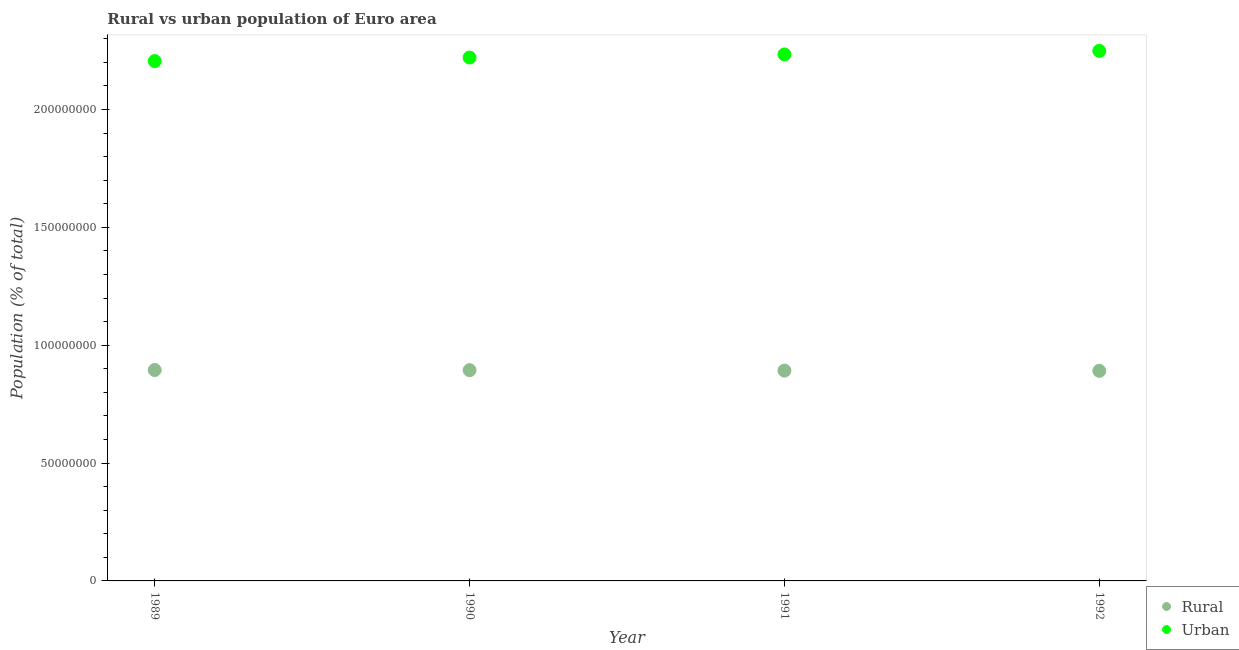What is the urban population density in 1992?
Your answer should be compact. 2.25e+08. Across all years, what is the maximum urban population density?
Offer a terse response. 2.25e+08. Across all years, what is the minimum rural population density?
Provide a succinct answer. 8.91e+07. In which year was the rural population density minimum?
Make the answer very short. 1992. What is the total urban population density in the graph?
Offer a terse response. 8.91e+08. What is the difference between the rural population density in 1989 and that in 1992?
Offer a very short reply. 3.51e+05. What is the difference between the urban population density in 1989 and the rural population density in 1990?
Keep it short and to the point. 1.31e+08. What is the average rural population density per year?
Provide a short and direct response. 8.93e+07. In the year 1991, what is the difference between the urban population density and rural population density?
Make the answer very short. 1.34e+08. In how many years, is the rural population density greater than 90000000 %?
Keep it short and to the point. 0. What is the ratio of the urban population density in 1989 to that in 1990?
Make the answer very short. 0.99. Is the urban population density in 1989 less than that in 1991?
Offer a very short reply. Yes. Is the difference between the urban population density in 1989 and 1990 greater than the difference between the rural population density in 1989 and 1990?
Offer a terse response. No. What is the difference between the highest and the second highest urban population density?
Your response must be concise. 1.51e+06. What is the difference between the highest and the lowest urban population density?
Keep it short and to the point. 4.34e+06. Is the urban population density strictly greater than the rural population density over the years?
Give a very brief answer. Yes. Is the urban population density strictly less than the rural population density over the years?
Provide a short and direct response. No. How many dotlines are there?
Your answer should be compact. 2. What is the difference between two consecutive major ticks on the Y-axis?
Ensure brevity in your answer.  5.00e+07. Are the values on the major ticks of Y-axis written in scientific E-notation?
Offer a terse response. No. How many legend labels are there?
Ensure brevity in your answer.  2. What is the title of the graph?
Give a very brief answer. Rural vs urban population of Euro area. Does "Non-residents" appear as one of the legend labels in the graph?
Your answer should be very brief. No. What is the label or title of the Y-axis?
Your answer should be very brief. Population (% of total). What is the Population (% of total) in Rural in 1989?
Give a very brief answer. 8.95e+07. What is the Population (% of total) of Urban in 1989?
Provide a succinct answer. 2.21e+08. What is the Population (% of total) of Rural in 1990?
Provide a short and direct response. 8.94e+07. What is the Population (% of total) in Urban in 1990?
Make the answer very short. 2.22e+08. What is the Population (% of total) in Rural in 1991?
Provide a short and direct response. 8.92e+07. What is the Population (% of total) of Urban in 1991?
Give a very brief answer. 2.23e+08. What is the Population (% of total) in Rural in 1992?
Make the answer very short. 8.91e+07. What is the Population (% of total) in Urban in 1992?
Make the answer very short. 2.25e+08. Across all years, what is the maximum Population (% of total) in Rural?
Your response must be concise. 8.95e+07. Across all years, what is the maximum Population (% of total) of Urban?
Provide a short and direct response. 2.25e+08. Across all years, what is the minimum Population (% of total) in Rural?
Provide a succinct answer. 8.91e+07. Across all years, what is the minimum Population (% of total) in Urban?
Make the answer very short. 2.21e+08. What is the total Population (% of total) of Rural in the graph?
Make the answer very short. 3.57e+08. What is the total Population (% of total) in Urban in the graph?
Your answer should be compact. 8.91e+08. What is the difference between the Population (% of total) in Rural in 1989 and that in 1990?
Make the answer very short. 6.82e+04. What is the difference between the Population (% of total) in Urban in 1989 and that in 1990?
Provide a succinct answer. -1.51e+06. What is the difference between the Population (% of total) of Rural in 1989 and that in 1991?
Provide a short and direct response. 2.69e+05. What is the difference between the Population (% of total) in Urban in 1989 and that in 1991?
Provide a short and direct response. -2.84e+06. What is the difference between the Population (% of total) of Rural in 1989 and that in 1992?
Keep it short and to the point. 3.51e+05. What is the difference between the Population (% of total) of Urban in 1989 and that in 1992?
Provide a short and direct response. -4.34e+06. What is the difference between the Population (% of total) in Rural in 1990 and that in 1991?
Your answer should be very brief. 2.01e+05. What is the difference between the Population (% of total) in Urban in 1990 and that in 1991?
Ensure brevity in your answer.  -1.33e+06. What is the difference between the Population (% of total) in Rural in 1990 and that in 1992?
Provide a short and direct response. 2.83e+05. What is the difference between the Population (% of total) of Urban in 1990 and that in 1992?
Offer a very short reply. -2.84e+06. What is the difference between the Population (% of total) of Rural in 1991 and that in 1992?
Offer a very short reply. 8.13e+04. What is the difference between the Population (% of total) of Urban in 1991 and that in 1992?
Keep it short and to the point. -1.51e+06. What is the difference between the Population (% of total) in Rural in 1989 and the Population (% of total) in Urban in 1990?
Your answer should be very brief. -1.33e+08. What is the difference between the Population (% of total) of Rural in 1989 and the Population (% of total) of Urban in 1991?
Keep it short and to the point. -1.34e+08. What is the difference between the Population (% of total) in Rural in 1989 and the Population (% of total) in Urban in 1992?
Keep it short and to the point. -1.35e+08. What is the difference between the Population (% of total) of Rural in 1990 and the Population (% of total) of Urban in 1991?
Provide a short and direct response. -1.34e+08. What is the difference between the Population (% of total) of Rural in 1990 and the Population (% of total) of Urban in 1992?
Offer a very short reply. -1.35e+08. What is the difference between the Population (% of total) in Rural in 1991 and the Population (% of total) in Urban in 1992?
Make the answer very short. -1.36e+08. What is the average Population (% of total) of Rural per year?
Offer a terse response. 8.93e+07. What is the average Population (% of total) of Urban per year?
Make the answer very short. 2.23e+08. In the year 1989, what is the difference between the Population (% of total) in Rural and Population (% of total) in Urban?
Offer a terse response. -1.31e+08. In the year 1990, what is the difference between the Population (% of total) in Rural and Population (% of total) in Urban?
Your answer should be compact. -1.33e+08. In the year 1991, what is the difference between the Population (% of total) in Rural and Population (% of total) in Urban?
Give a very brief answer. -1.34e+08. In the year 1992, what is the difference between the Population (% of total) in Rural and Population (% of total) in Urban?
Keep it short and to the point. -1.36e+08. What is the ratio of the Population (% of total) of Rural in 1989 to that in 1990?
Make the answer very short. 1. What is the ratio of the Population (% of total) of Rural in 1989 to that in 1991?
Make the answer very short. 1. What is the ratio of the Population (% of total) of Urban in 1989 to that in 1991?
Provide a succinct answer. 0.99. What is the ratio of the Population (% of total) of Rural in 1989 to that in 1992?
Ensure brevity in your answer.  1. What is the ratio of the Population (% of total) of Urban in 1989 to that in 1992?
Provide a succinct answer. 0.98. What is the ratio of the Population (% of total) of Rural in 1990 to that in 1991?
Make the answer very short. 1. What is the ratio of the Population (% of total) of Urban in 1990 to that in 1992?
Provide a succinct answer. 0.99. What is the ratio of the Population (% of total) in Urban in 1991 to that in 1992?
Keep it short and to the point. 0.99. What is the difference between the highest and the second highest Population (% of total) in Rural?
Your answer should be compact. 6.82e+04. What is the difference between the highest and the second highest Population (% of total) in Urban?
Your answer should be compact. 1.51e+06. What is the difference between the highest and the lowest Population (% of total) in Rural?
Ensure brevity in your answer.  3.51e+05. What is the difference between the highest and the lowest Population (% of total) in Urban?
Make the answer very short. 4.34e+06. 